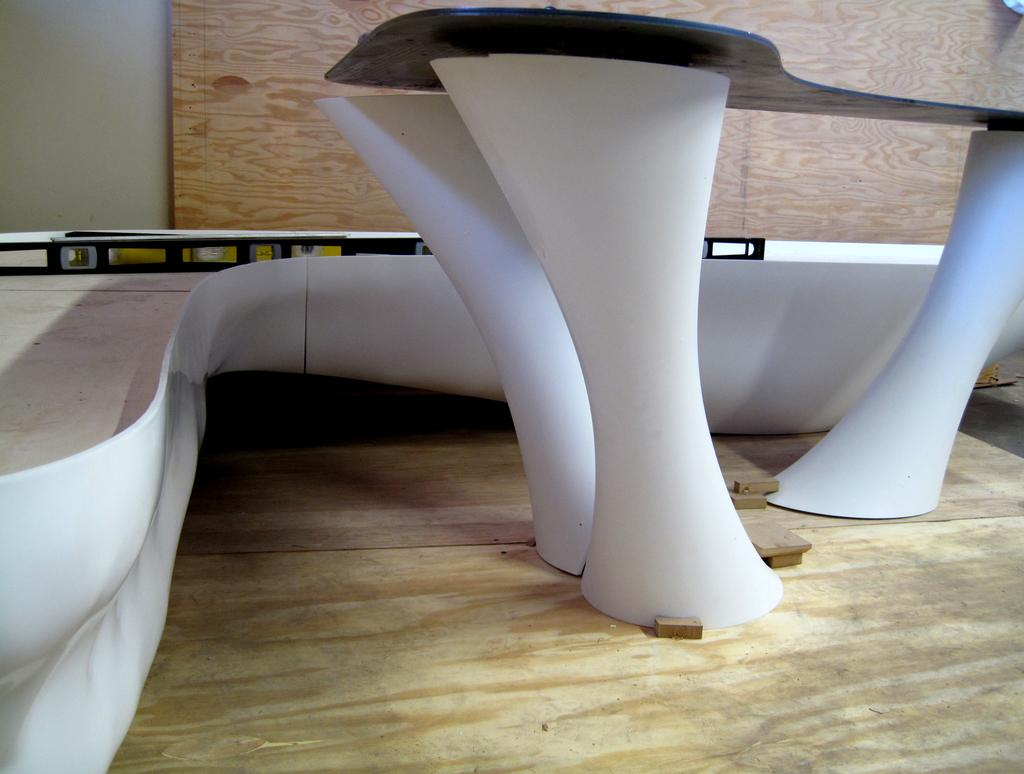What piece of furniture is present in the image? There is a table in the image. What can be seen in the background of the image? There is an object and a wooden wall in the background of the image. What type of collar is being used to shock the object in the image? There is no collar or shocking action present in the image. The image only features a table, an object, and a wooden wall in the background. 